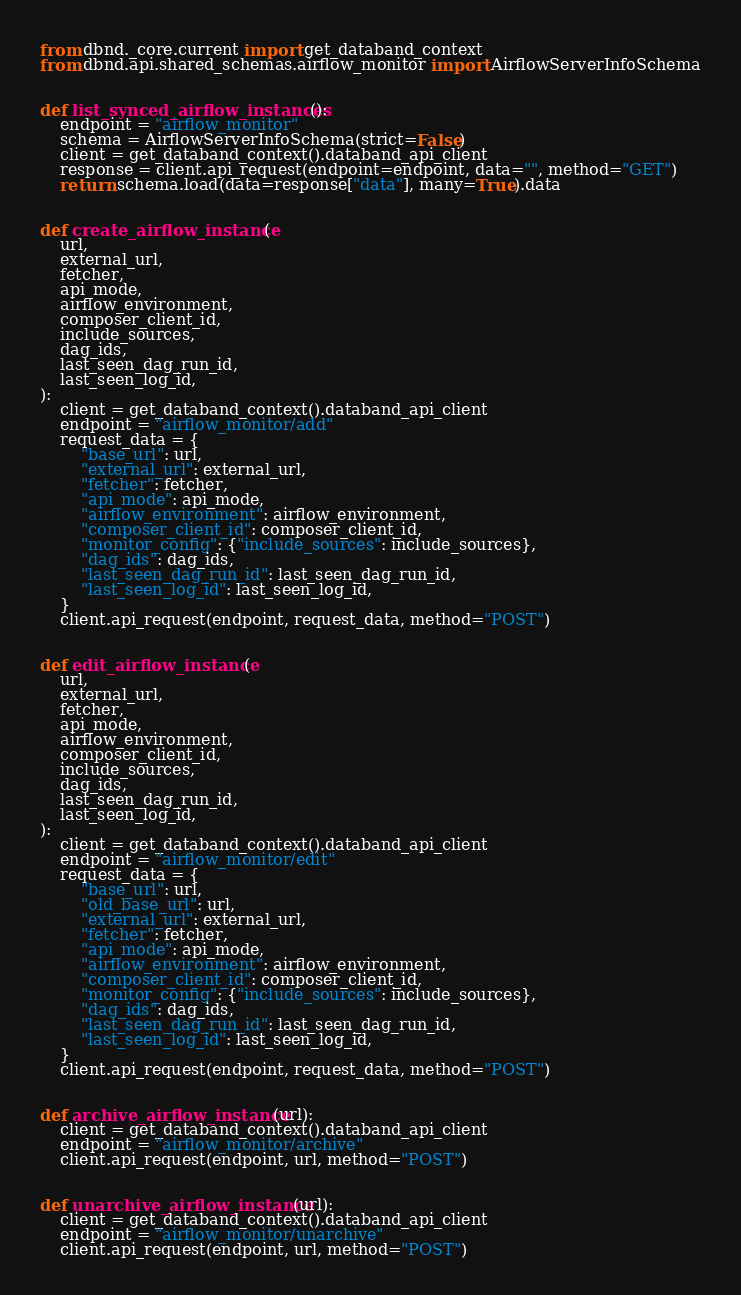Convert code to text. <code><loc_0><loc_0><loc_500><loc_500><_Python_>from dbnd._core.current import get_databand_context
from dbnd.api.shared_schemas.airflow_monitor import AirflowServerInfoSchema


def list_synced_airflow_instances():
    endpoint = "airflow_monitor"
    schema = AirflowServerInfoSchema(strict=False)
    client = get_databand_context().databand_api_client
    response = client.api_request(endpoint=endpoint, data="", method="GET")
    return schema.load(data=response["data"], many=True).data


def create_airflow_instance(
    url,
    external_url,
    fetcher,
    api_mode,
    airflow_environment,
    composer_client_id,
    include_sources,
    dag_ids,
    last_seen_dag_run_id,
    last_seen_log_id,
):
    client = get_databand_context().databand_api_client
    endpoint = "airflow_monitor/add"
    request_data = {
        "base_url": url,
        "external_url": external_url,
        "fetcher": fetcher,
        "api_mode": api_mode,
        "airflow_environment": airflow_environment,
        "composer_client_id": composer_client_id,
        "monitor_config": {"include_sources": include_sources},
        "dag_ids": dag_ids,
        "last_seen_dag_run_id": last_seen_dag_run_id,
        "last_seen_log_id": last_seen_log_id,
    }
    client.api_request(endpoint, request_data, method="POST")


def edit_airflow_instance(
    url,
    external_url,
    fetcher,
    api_mode,
    airflow_environment,
    composer_client_id,
    include_sources,
    dag_ids,
    last_seen_dag_run_id,
    last_seen_log_id,
):
    client = get_databand_context().databand_api_client
    endpoint = "airflow_monitor/edit"
    request_data = {
        "base_url": url,
        "old_base_url": url,
        "external_url": external_url,
        "fetcher": fetcher,
        "api_mode": api_mode,
        "airflow_environment": airflow_environment,
        "composer_client_id": composer_client_id,
        "monitor_config": {"include_sources": include_sources},
        "dag_ids": dag_ids,
        "last_seen_dag_run_id": last_seen_dag_run_id,
        "last_seen_log_id": last_seen_log_id,
    }
    client.api_request(endpoint, request_data, method="POST")


def archive_airflow_instance(url):
    client = get_databand_context().databand_api_client
    endpoint = "airflow_monitor/archive"
    client.api_request(endpoint, url, method="POST")


def unarchive_airflow_instance(url):
    client = get_databand_context().databand_api_client
    endpoint = "airflow_monitor/unarchive"
    client.api_request(endpoint, url, method="POST")
</code> 